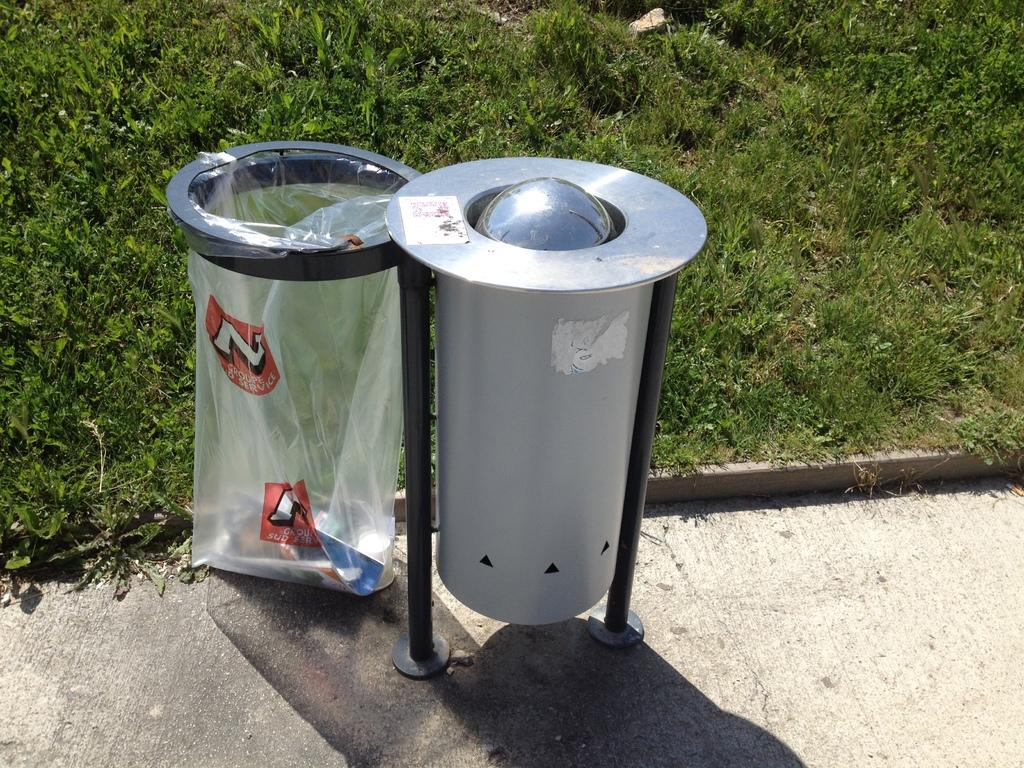<image>
Write a terse but informative summary of the picture. a plastic bag next to a silver container that has an 'n' onit 